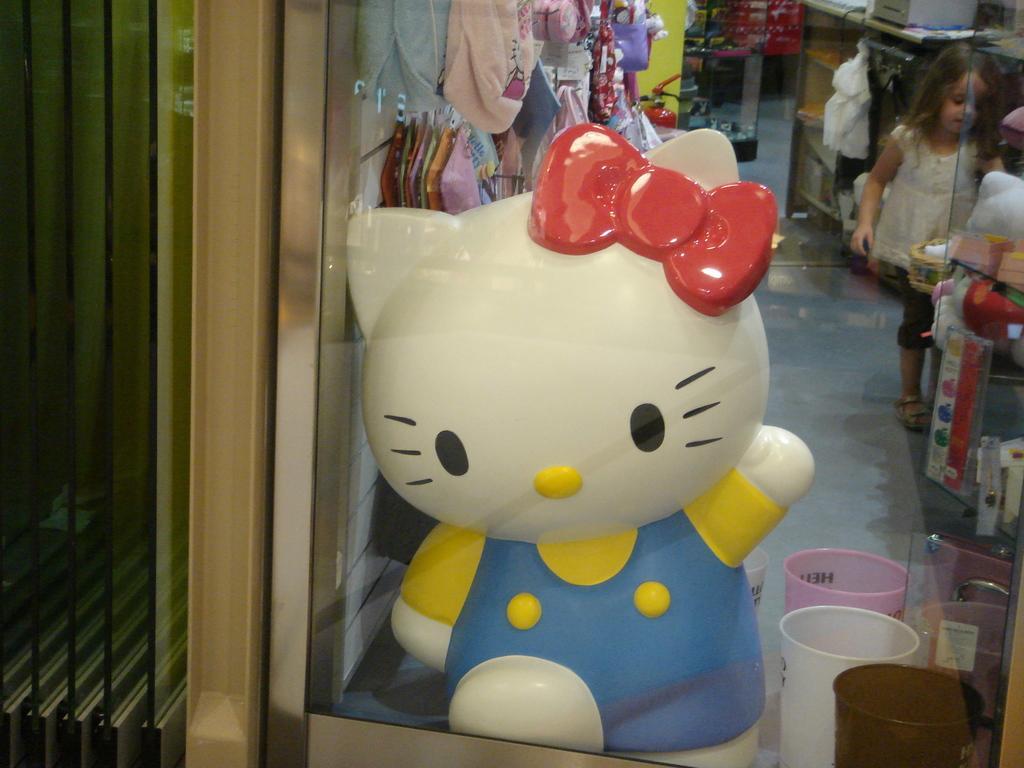Please provide a concise description of this image. In this picture, we see a toy in white, yellow, blue and red color. Beside that, we see the glasses. Behind the toy, we see the clothes and the bags. On the right side, we see a girl is standing. In front of her, we see the objects. Behind her, we see a table on which the objects are placed. In the background, we see a rack in which the red color objects are placed. On the left side, we see a glass door. 